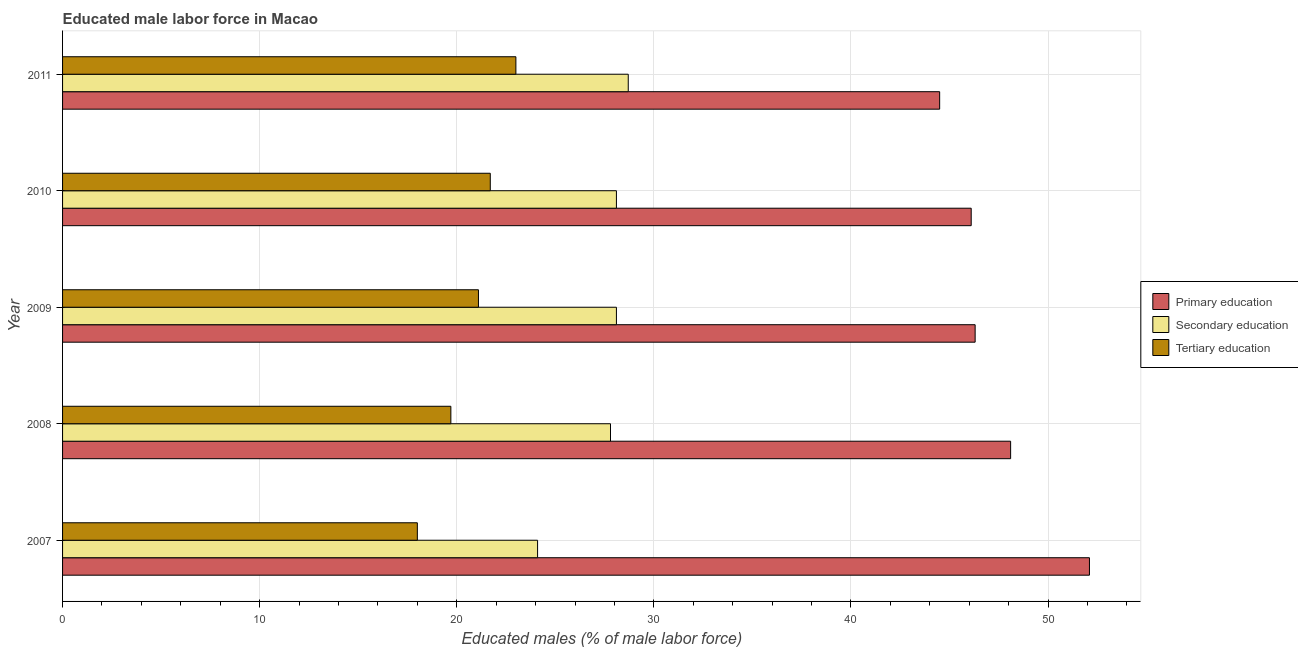How many different coloured bars are there?
Offer a very short reply. 3. How many groups of bars are there?
Your answer should be compact. 5. How many bars are there on the 5th tick from the top?
Your answer should be compact. 3. What is the percentage of male labor force who received secondary education in 2008?
Your response must be concise. 27.8. Across all years, what is the maximum percentage of male labor force who received secondary education?
Keep it short and to the point. 28.7. What is the total percentage of male labor force who received tertiary education in the graph?
Your answer should be compact. 103.5. What is the difference between the percentage of male labor force who received secondary education in 2007 and that in 2010?
Offer a terse response. -4. What is the difference between the percentage of male labor force who received tertiary education in 2007 and the percentage of male labor force who received secondary education in 2008?
Provide a succinct answer. -9.8. What is the average percentage of male labor force who received primary education per year?
Provide a short and direct response. 47.42. In the year 2010, what is the difference between the percentage of male labor force who received primary education and percentage of male labor force who received secondary education?
Give a very brief answer. 18. What is the ratio of the percentage of male labor force who received tertiary education in 2010 to that in 2011?
Offer a very short reply. 0.94. Is the percentage of male labor force who received secondary education in 2007 less than that in 2010?
Offer a very short reply. Yes. Is the difference between the percentage of male labor force who received primary education in 2008 and 2011 greater than the difference between the percentage of male labor force who received secondary education in 2008 and 2011?
Offer a terse response. Yes. What is the difference between the highest and the lowest percentage of male labor force who received primary education?
Provide a succinct answer. 7.6. What does the 2nd bar from the top in 2007 represents?
Keep it short and to the point. Secondary education. What does the 3rd bar from the bottom in 2008 represents?
Offer a terse response. Tertiary education. How many bars are there?
Provide a short and direct response. 15. Does the graph contain any zero values?
Your answer should be compact. No. Does the graph contain grids?
Offer a terse response. Yes. What is the title of the graph?
Give a very brief answer. Educated male labor force in Macao. What is the label or title of the X-axis?
Provide a short and direct response. Educated males (% of male labor force). What is the label or title of the Y-axis?
Give a very brief answer. Year. What is the Educated males (% of male labor force) in Primary education in 2007?
Make the answer very short. 52.1. What is the Educated males (% of male labor force) in Secondary education in 2007?
Keep it short and to the point. 24.1. What is the Educated males (% of male labor force) in Primary education in 2008?
Keep it short and to the point. 48.1. What is the Educated males (% of male labor force) of Secondary education in 2008?
Offer a very short reply. 27.8. What is the Educated males (% of male labor force) in Tertiary education in 2008?
Your response must be concise. 19.7. What is the Educated males (% of male labor force) of Primary education in 2009?
Offer a terse response. 46.3. What is the Educated males (% of male labor force) in Secondary education in 2009?
Offer a terse response. 28.1. What is the Educated males (% of male labor force) in Tertiary education in 2009?
Give a very brief answer. 21.1. What is the Educated males (% of male labor force) of Primary education in 2010?
Your answer should be very brief. 46.1. What is the Educated males (% of male labor force) of Secondary education in 2010?
Provide a succinct answer. 28.1. What is the Educated males (% of male labor force) of Tertiary education in 2010?
Your response must be concise. 21.7. What is the Educated males (% of male labor force) of Primary education in 2011?
Ensure brevity in your answer.  44.5. What is the Educated males (% of male labor force) of Secondary education in 2011?
Your answer should be very brief. 28.7. Across all years, what is the maximum Educated males (% of male labor force) in Primary education?
Keep it short and to the point. 52.1. Across all years, what is the maximum Educated males (% of male labor force) in Secondary education?
Offer a terse response. 28.7. Across all years, what is the maximum Educated males (% of male labor force) of Tertiary education?
Give a very brief answer. 23. Across all years, what is the minimum Educated males (% of male labor force) in Primary education?
Give a very brief answer. 44.5. Across all years, what is the minimum Educated males (% of male labor force) of Secondary education?
Offer a very short reply. 24.1. Across all years, what is the minimum Educated males (% of male labor force) in Tertiary education?
Make the answer very short. 18. What is the total Educated males (% of male labor force) of Primary education in the graph?
Keep it short and to the point. 237.1. What is the total Educated males (% of male labor force) in Secondary education in the graph?
Keep it short and to the point. 136.8. What is the total Educated males (% of male labor force) of Tertiary education in the graph?
Provide a succinct answer. 103.5. What is the difference between the Educated males (% of male labor force) of Primary education in 2007 and that in 2008?
Your answer should be compact. 4. What is the difference between the Educated males (% of male labor force) in Tertiary education in 2007 and that in 2008?
Your answer should be very brief. -1.7. What is the difference between the Educated males (% of male labor force) in Primary education in 2007 and that in 2009?
Your answer should be compact. 5.8. What is the difference between the Educated males (% of male labor force) of Secondary education in 2007 and that in 2009?
Provide a short and direct response. -4. What is the difference between the Educated males (% of male labor force) of Tertiary education in 2007 and that in 2009?
Your response must be concise. -3.1. What is the difference between the Educated males (% of male labor force) of Primary education in 2007 and that in 2010?
Provide a short and direct response. 6. What is the difference between the Educated males (% of male labor force) of Secondary education in 2007 and that in 2010?
Make the answer very short. -4. What is the difference between the Educated males (% of male labor force) of Tertiary education in 2007 and that in 2010?
Your response must be concise. -3.7. What is the difference between the Educated males (% of male labor force) of Primary education in 2007 and that in 2011?
Offer a very short reply. 7.6. What is the difference between the Educated males (% of male labor force) of Tertiary education in 2007 and that in 2011?
Your answer should be compact. -5. What is the difference between the Educated males (% of male labor force) in Primary education in 2008 and that in 2010?
Keep it short and to the point. 2. What is the difference between the Educated males (% of male labor force) of Tertiary education in 2008 and that in 2010?
Your answer should be very brief. -2. What is the difference between the Educated males (% of male labor force) of Tertiary education in 2008 and that in 2011?
Offer a terse response. -3.3. What is the difference between the Educated males (% of male labor force) of Primary education in 2009 and that in 2010?
Offer a very short reply. 0.2. What is the difference between the Educated males (% of male labor force) of Secondary education in 2009 and that in 2011?
Give a very brief answer. -0.6. What is the difference between the Educated males (% of male labor force) of Primary education in 2010 and that in 2011?
Provide a short and direct response. 1.6. What is the difference between the Educated males (% of male labor force) of Tertiary education in 2010 and that in 2011?
Your answer should be compact. -1.3. What is the difference between the Educated males (% of male labor force) in Primary education in 2007 and the Educated males (% of male labor force) in Secondary education in 2008?
Your answer should be compact. 24.3. What is the difference between the Educated males (% of male labor force) in Primary education in 2007 and the Educated males (% of male labor force) in Tertiary education in 2008?
Make the answer very short. 32.4. What is the difference between the Educated males (% of male labor force) of Secondary education in 2007 and the Educated males (% of male labor force) of Tertiary education in 2008?
Provide a short and direct response. 4.4. What is the difference between the Educated males (% of male labor force) in Primary education in 2007 and the Educated males (% of male labor force) in Secondary education in 2009?
Keep it short and to the point. 24. What is the difference between the Educated males (% of male labor force) in Primary education in 2007 and the Educated males (% of male labor force) in Tertiary education in 2010?
Your response must be concise. 30.4. What is the difference between the Educated males (% of male labor force) in Secondary education in 2007 and the Educated males (% of male labor force) in Tertiary education in 2010?
Keep it short and to the point. 2.4. What is the difference between the Educated males (% of male labor force) of Primary education in 2007 and the Educated males (% of male labor force) of Secondary education in 2011?
Keep it short and to the point. 23.4. What is the difference between the Educated males (% of male labor force) in Primary education in 2007 and the Educated males (% of male labor force) in Tertiary education in 2011?
Provide a short and direct response. 29.1. What is the difference between the Educated males (% of male labor force) in Secondary education in 2007 and the Educated males (% of male labor force) in Tertiary education in 2011?
Provide a succinct answer. 1.1. What is the difference between the Educated males (% of male labor force) of Primary education in 2008 and the Educated males (% of male labor force) of Secondary education in 2009?
Offer a terse response. 20. What is the difference between the Educated males (% of male labor force) in Secondary education in 2008 and the Educated males (% of male labor force) in Tertiary education in 2009?
Ensure brevity in your answer.  6.7. What is the difference between the Educated males (% of male labor force) in Primary education in 2008 and the Educated males (% of male labor force) in Secondary education in 2010?
Provide a succinct answer. 20. What is the difference between the Educated males (% of male labor force) of Primary education in 2008 and the Educated males (% of male labor force) of Tertiary education in 2010?
Give a very brief answer. 26.4. What is the difference between the Educated males (% of male labor force) in Secondary education in 2008 and the Educated males (% of male labor force) in Tertiary education in 2010?
Your response must be concise. 6.1. What is the difference between the Educated males (% of male labor force) in Primary education in 2008 and the Educated males (% of male labor force) in Tertiary education in 2011?
Your answer should be compact. 25.1. What is the difference between the Educated males (% of male labor force) of Primary education in 2009 and the Educated males (% of male labor force) of Secondary education in 2010?
Your answer should be very brief. 18.2. What is the difference between the Educated males (% of male labor force) of Primary education in 2009 and the Educated males (% of male labor force) of Tertiary education in 2010?
Give a very brief answer. 24.6. What is the difference between the Educated males (% of male labor force) in Secondary education in 2009 and the Educated males (% of male labor force) in Tertiary education in 2010?
Give a very brief answer. 6.4. What is the difference between the Educated males (% of male labor force) in Primary education in 2009 and the Educated males (% of male labor force) in Secondary education in 2011?
Keep it short and to the point. 17.6. What is the difference between the Educated males (% of male labor force) in Primary education in 2009 and the Educated males (% of male labor force) in Tertiary education in 2011?
Your answer should be compact. 23.3. What is the difference between the Educated males (% of male labor force) of Secondary education in 2009 and the Educated males (% of male labor force) of Tertiary education in 2011?
Your response must be concise. 5.1. What is the difference between the Educated males (% of male labor force) of Primary education in 2010 and the Educated males (% of male labor force) of Tertiary education in 2011?
Provide a succinct answer. 23.1. What is the difference between the Educated males (% of male labor force) in Secondary education in 2010 and the Educated males (% of male labor force) in Tertiary education in 2011?
Ensure brevity in your answer.  5.1. What is the average Educated males (% of male labor force) of Primary education per year?
Ensure brevity in your answer.  47.42. What is the average Educated males (% of male labor force) in Secondary education per year?
Keep it short and to the point. 27.36. What is the average Educated males (% of male labor force) of Tertiary education per year?
Offer a very short reply. 20.7. In the year 2007, what is the difference between the Educated males (% of male labor force) of Primary education and Educated males (% of male labor force) of Secondary education?
Your response must be concise. 28. In the year 2007, what is the difference between the Educated males (% of male labor force) in Primary education and Educated males (% of male labor force) in Tertiary education?
Make the answer very short. 34.1. In the year 2007, what is the difference between the Educated males (% of male labor force) of Secondary education and Educated males (% of male labor force) of Tertiary education?
Your answer should be compact. 6.1. In the year 2008, what is the difference between the Educated males (% of male labor force) of Primary education and Educated males (% of male labor force) of Secondary education?
Provide a short and direct response. 20.3. In the year 2008, what is the difference between the Educated males (% of male labor force) of Primary education and Educated males (% of male labor force) of Tertiary education?
Offer a very short reply. 28.4. In the year 2008, what is the difference between the Educated males (% of male labor force) of Secondary education and Educated males (% of male labor force) of Tertiary education?
Your answer should be very brief. 8.1. In the year 2009, what is the difference between the Educated males (% of male labor force) in Primary education and Educated males (% of male labor force) in Secondary education?
Offer a very short reply. 18.2. In the year 2009, what is the difference between the Educated males (% of male labor force) of Primary education and Educated males (% of male labor force) of Tertiary education?
Provide a short and direct response. 25.2. In the year 2010, what is the difference between the Educated males (% of male labor force) in Primary education and Educated males (% of male labor force) in Secondary education?
Keep it short and to the point. 18. In the year 2010, what is the difference between the Educated males (% of male labor force) in Primary education and Educated males (% of male labor force) in Tertiary education?
Make the answer very short. 24.4. In the year 2011, what is the difference between the Educated males (% of male labor force) in Primary education and Educated males (% of male labor force) in Secondary education?
Your answer should be compact. 15.8. In the year 2011, what is the difference between the Educated males (% of male labor force) in Primary education and Educated males (% of male labor force) in Tertiary education?
Provide a short and direct response. 21.5. What is the ratio of the Educated males (% of male labor force) of Primary education in 2007 to that in 2008?
Offer a very short reply. 1.08. What is the ratio of the Educated males (% of male labor force) in Secondary education in 2007 to that in 2008?
Ensure brevity in your answer.  0.87. What is the ratio of the Educated males (% of male labor force) in Tertiary education in 2007 to that in 2008?
Provide a succinct answer. 0.91. What is the ratio of the Educated males (% of male labor force) in Primary education in 2007 to that in 2009?
Your response must be concise. 1.13. What is the ratio of the Educated males (% of male labor force) in Secondary education in 2007 to that in 2009?
Give a very brief answer. 0.86. What is the ratio of the Educated males (% of male labor force) of Tertiary education in 2007 to that in 2009?
Your answer should be compact. 0.85. What is the ratio of the Educated males (% of male labor force) of Primary education in 2007 to that in 2010?
Your response must be concise. 1.13. What is the ratio of the Educated males (% of male labor force) of Secondary education in 2007 to that in 2010?
Your answer should be compact. 0.86. What is the ratio of the Educated males (% of male labor force) in Tertiary education in 2007 to that in 2010?
Make the answer very short. 0.83. What is the ratio of the Educated males (% of male labor force) in Primary education in 2007 to that in 2011?
Ensure brevity in your answer.  1.17. What is the ratio of the Educated males (% of male labor force) in Secondary education in 2007 to that in 2011?
Ensure brevity in your answer.  0.84. What is the ratio of the Educated males (% of male labor force) in Tertiary education in 2007 to that in 2011?
Offer a terse response. 0.78. What is the ratio of the Educated males (% of male labor force) in Primary education in 2008 to that in 2009?
Offer a terse response. 1.04. What is the ratio of the Educated males (% of male labor force) of Secondary education in 2008 to that in 2009?
Make the answer very short. 0.99. What is the ratio of the Educated males (% of male labor force) in Tertiary education in 2008 to that in 2009?
Ensure brevity in your answer.  0.93. What is the ratio of the Educated males (% of male labor force) in Primary education in 2008 to that in 2010?
Ensure brevity in your answer.  1.04. What is the ratio of the Educated males (% of male labor force) in Secondary education in 2008 to that in 2010?
Give a very brief answer. 0.99. What is the ratio of the Educated males (% of male labor force) of Tertiary education in 2008 to that in 2010?
Ensure brevity in your answer.  0.91. What is the ratio of the Educated males (% of male labor force) in Primary education in 2008 to that in 2011?
Keep it short and to the point. 1.08. What is the ratio of the Educated males (% of male labor force) in Secondary education in 2008 to that in 2011?
Offer a very short reply. 0.97. What is the ratio of the Educated males (% of male labor force) in Tertiary education in 2008 to that in 2011?
Your answer should be compact. 0.86. What is the ratio of the Educated males (% of male labor force) of Tertiary education in 2009 to that in 2010?
Your response must be concise. 0.97. What is the ratio of the Educated males (% of male labor force) in Primary education in 2009 to that in 2011?
Give a very brief answer. 1.04. What is the ratio of the Educated males (% of male labor force) of Secondary education in 2009 to that in 2011?
Offer a terse response. 0.98. What is the ratio of the Educated males (% of male labor force) of Tertiary education in 2009 to that in 2011?
Your answer should be very brief. 0.92. What is the ratio of the Educated males (% of male labor force) in Primary education in 2010 to that in 2011?
Give a very brief answer. 1.04. What is the ratio of the Educated males (% of male labor force) in Secondary education in 2010 to that in 2011?
Make the answer very short. 0.98. What is the ratio of the Educated males (% of male labor force) of Tertiary education in 2010 to that in 2011?
Make the answer very short. 0.94. What is the difference between the highest and the lowest Educated males (% of male labor force) in Secondary education?
Your response must be concise. 4.6. What is the difference between the highest and the lowest Educated males (% of male labor force) of Tertiary education?
Provide a short and direct response. 5. 